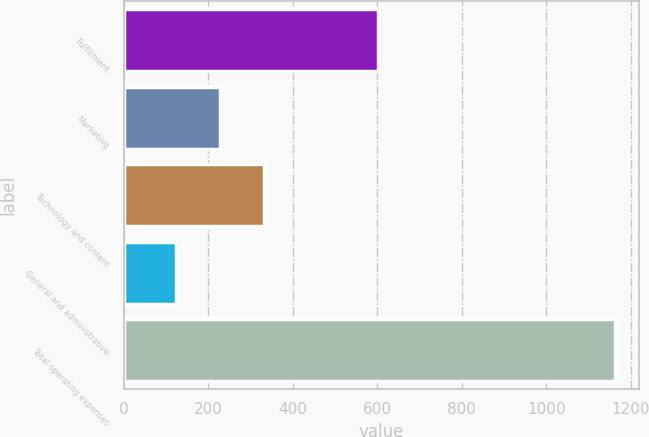Convert chart. <chart><loc_0><loc_0><loc_500><loc_500><bar_chart><fcel>Fulfillment<fcel>Marketing<fcel>Technology and content<fcel>General and administrative<fcel>Total operating expenses<nl><fcel>601<fcel>227.8<fcel>331.6<fcel>124<fcel>1162<nl></chart> 